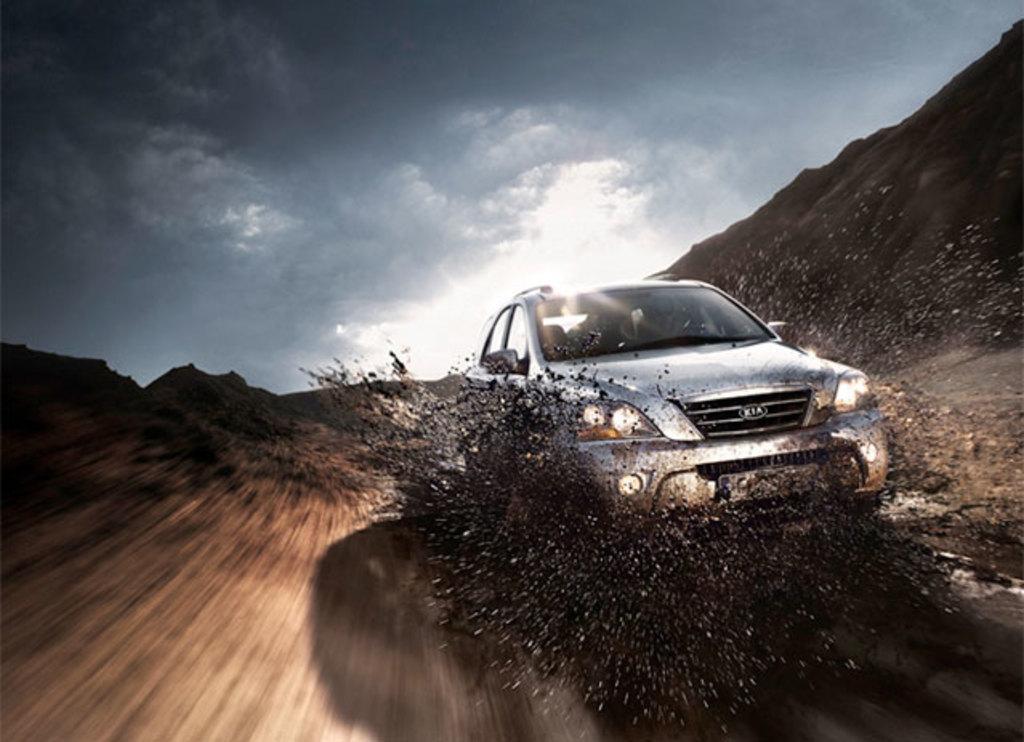Can you describe this image briefly? This image consists of a car. At the bottom, there is sand. It looks like a desert. At the top, there is a sky. 